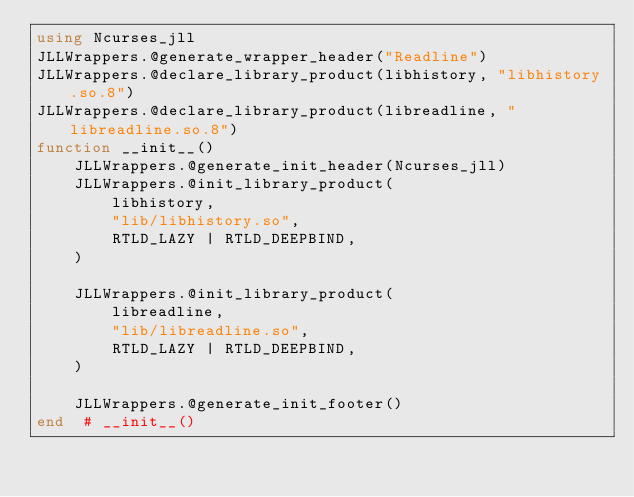Convert code to text. <code><loc_0><loc_0><loc_500><loc_500><_Julia_>using Ncurses_jll
JLLWrappers.@generate_wrapper_header("Readline")
JLLWrappers.@declare_library_product(libhistory, "libhistory.so.8")
JLLWrappers.@declare_library_product(libreadline, "libreadline.so.8")
function __init__()
    JLLWrappers.@generate_init_header(Ncurses_jll)
    JLLWrappers.@init_library_product(
        libhistory,
        "lib/libhistory.so",
        RTLD_LAZY | RTLD_DEEPBIND,
    )

    JLLWrappers.@init_library_product(
        libreadline,
        "lib/libreadline.so",
        RTLD_LAZY | RTLD_DEEPBIND,
    )

    JLLWrappers.@generate_init_footer()
end  # __init__()
</code> 